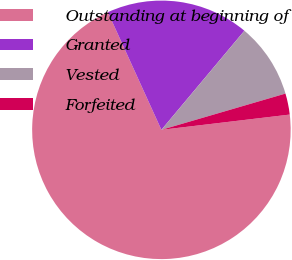Convert chart to OTSL. <chart><loc_0><loc_0><loc_500><loc_500><pie_chart><fcel>Outstanding at beginning of<fcel>Granted<fcel>Vested<fcel>Forfeited<nl><fcel>70.09%<fcel>17.89%<fcel>9.38%<fcel>2.64%<nl></chart> 